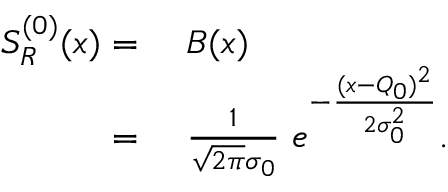<formula> <loc_0><loc_0><loc_500><loc_500>\begin{array} { r l } { S _ { R } ^ { ( 0 ) } ( x ) = \ } & B ( x ) } \\ { = \ } & \frac { 1 } { \sqrt { 2 \pi } \sigma _ { 0 } } \ e ^ { - \frac { ( x - Q _ { 0 } ) ^ { 2 } } { 2 \sigma _ { 0 } ^ { 2 } } } . } \end{array}</formula> 